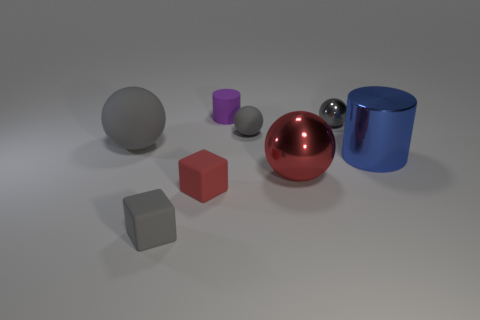Are there an equal number of tiny cylinders on the left side of the tiny purple matte cylinder and gray matte objects?
Give a very brief answer. No. There is a small gray matte object in front of the large gray thing; is it the same shape as the gray shiny thing?
Your answer should be very brief. No. The blue metal thing is what shape?
Keep it short and to the point. Cylinder. The big sphere that is right of the tiny gray matte object that is left of the cylinder that is left of the big red object is made of what material?
Make the answer very short. Metal. What is the material of the cube that is the same color as the large matte object?
Make the answer very short. Rubber. What number of things are small gray rubber cubes or blue blocks?
Keep it short and to the point. 1. Is the tiny object to the right of the big red metal thing made of the same material as the big cylinder?
Your answer should be very brief. Yes. How many objects are either small gray things on the right side of the tiny cylinder or red matte things?
Give a very brief answer. 3. What color is the tiny cylinder that is made of the same material as the gray block?
Offer a very short reply. Purple. Is there a brown matte block that has the same size as the purple cylinder?
Ensure brevity in your answer.  No. 